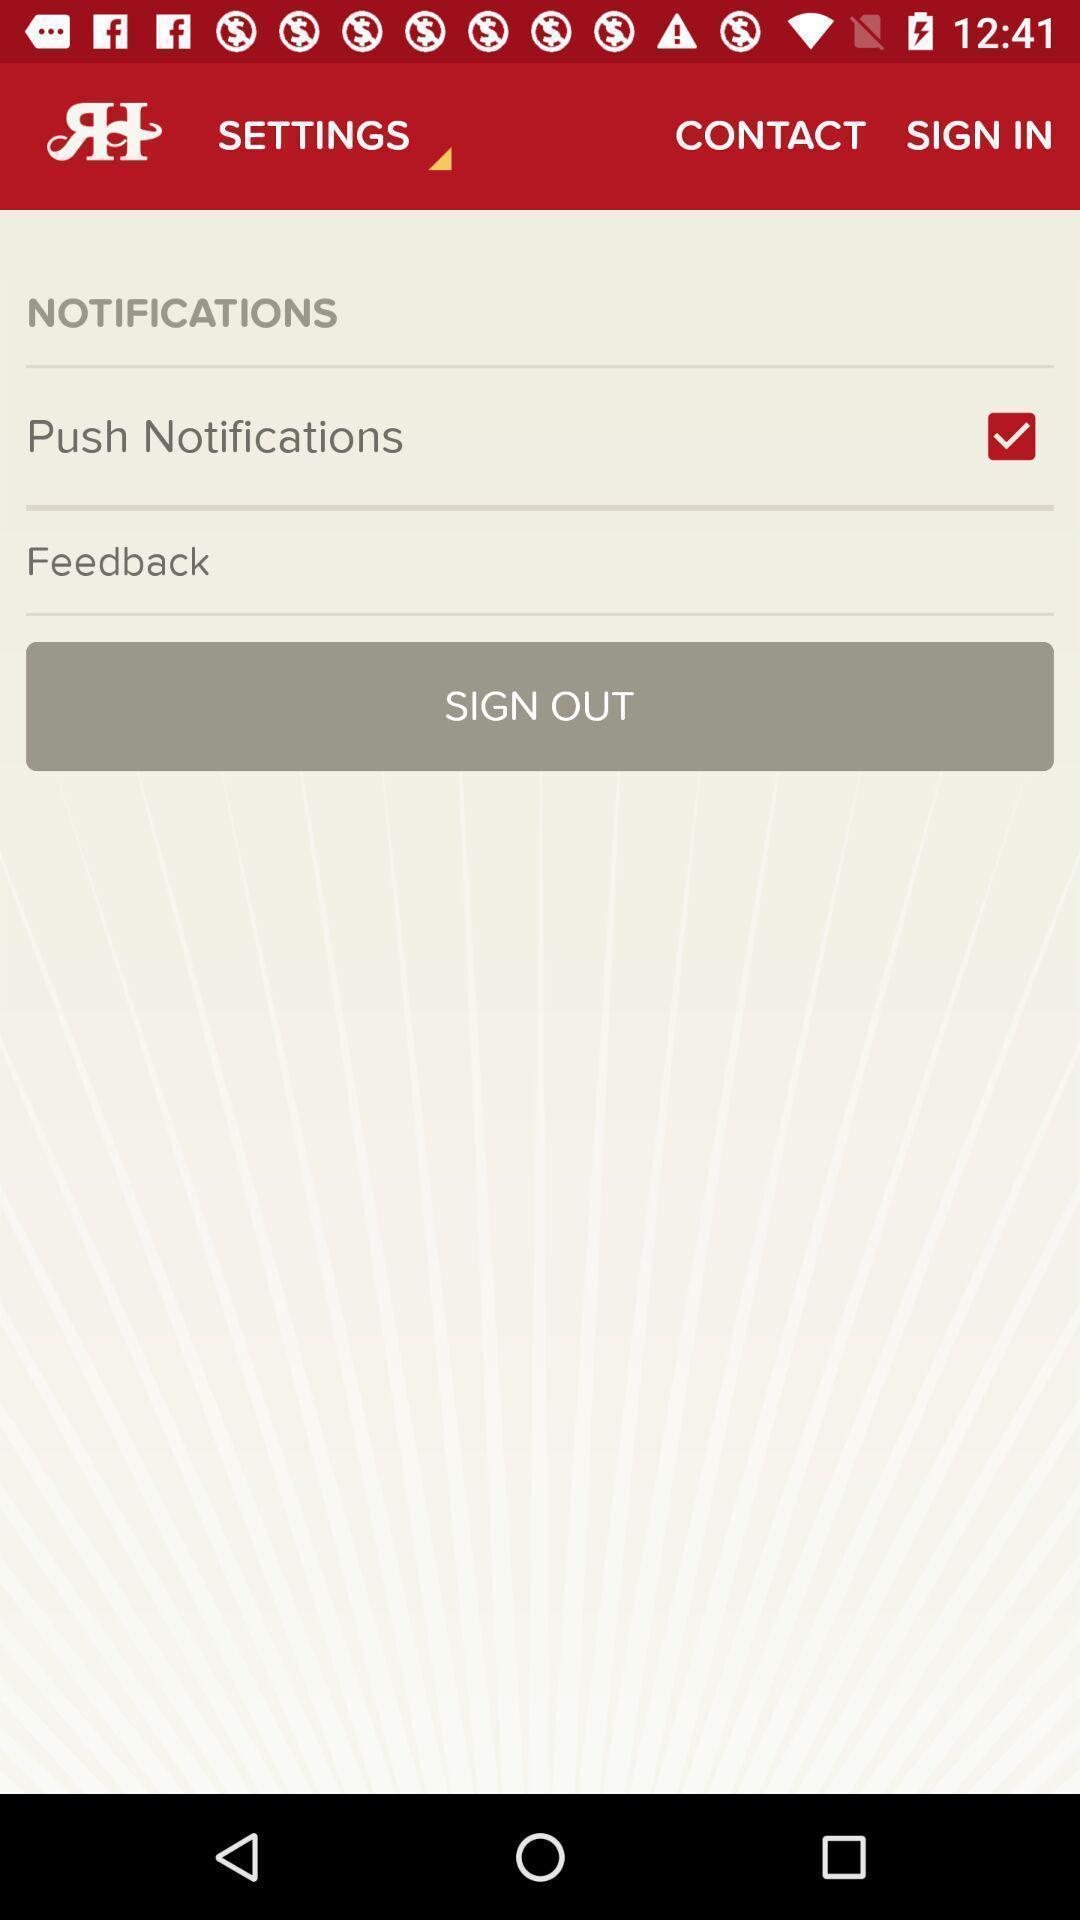What is the overall content of this screenshot? Sign out page. 